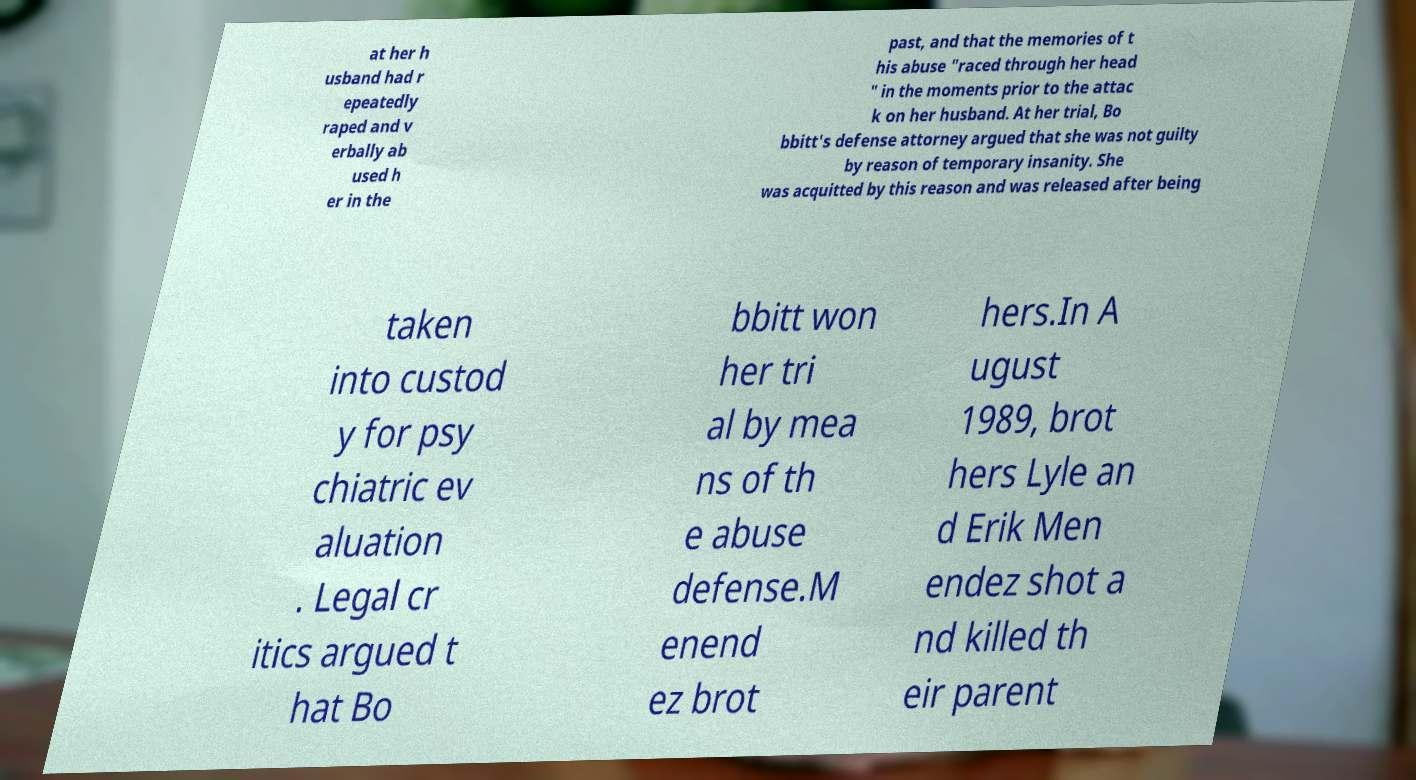Please read and relay the text visible in this image. What does it say? at her h usband had r epeatedly raped and v erbally ab used h er in the past, and that the memories of t his abuse "raced through her head " in the moments prior to the attac k on her husband. At her trial, Bo bbitt's defense attorney argued that she was not guilty by reason of temporary insanity. She was acquitted by this reason and was released after being taken into custod y for psy chiatric ev aluation . Legal cr itics argued t hat Bo bbitt won her tri al by mea ns of th e abuse defense.M enend ez brot hers.In A ugust 1989, brot hers Lyle an d Erik Men endez shot a nd killed th eir parent 